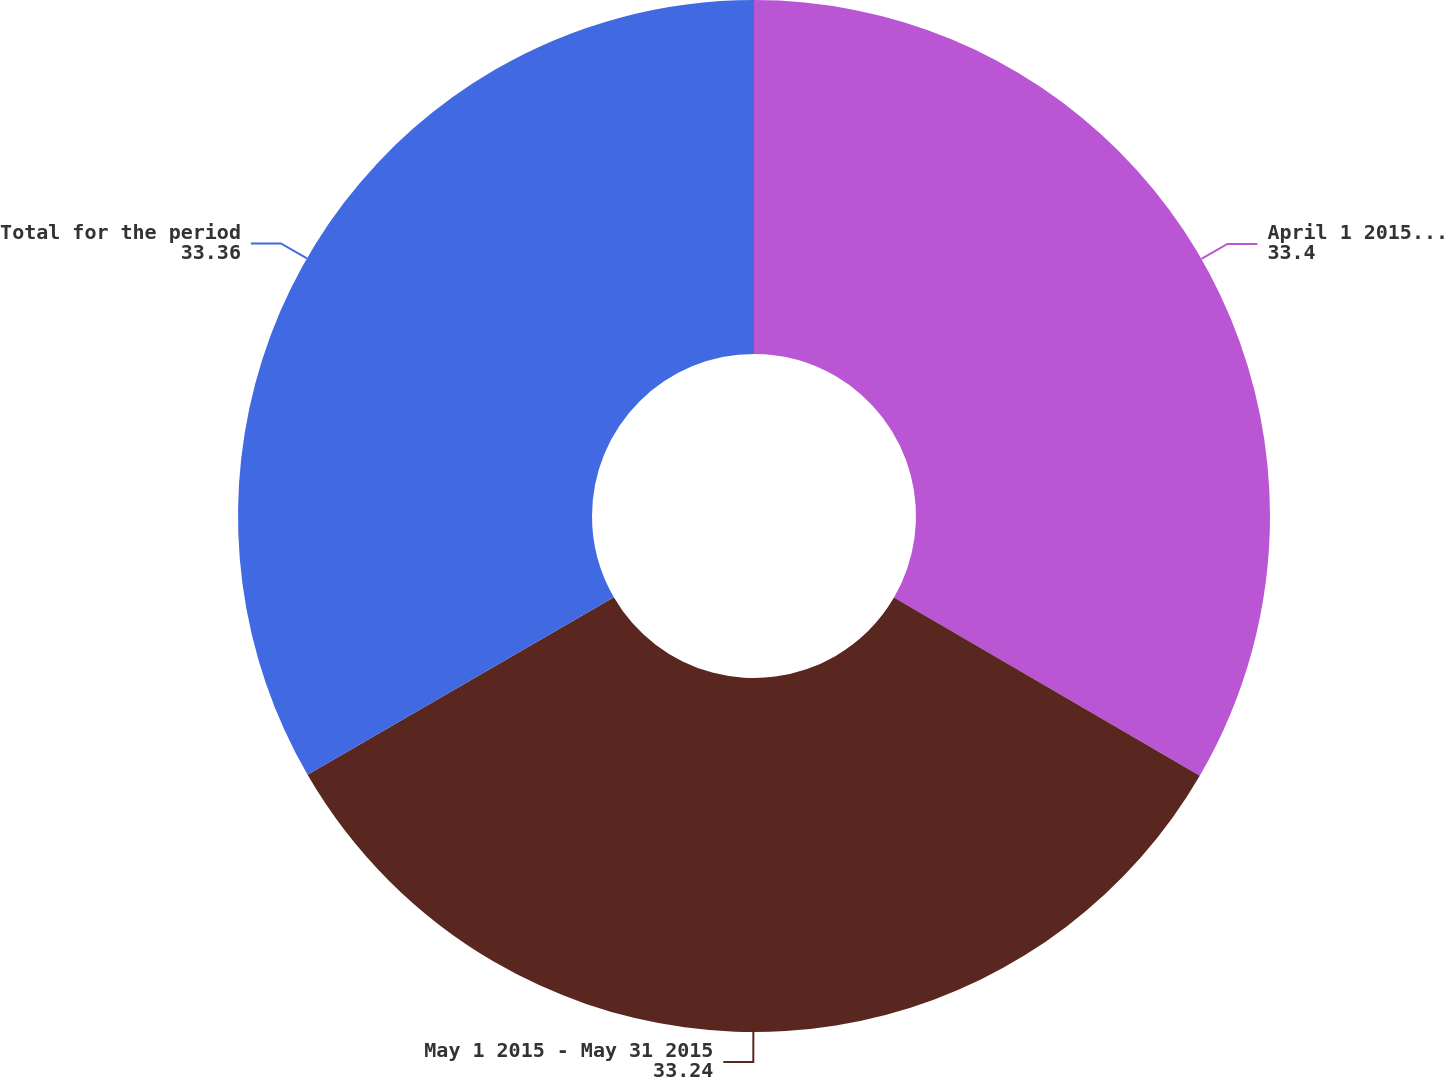Convert chart to OTSL. <chart><loc_0><loc_0><loc_500><loc_500><pie_chart><fcel>April 1 2015 - April 30 2015<fcel>May 1 2015 - May 31 2015<fcel>Total for the period<nl><fcel>33.4%<fcel>33.24%<fcel>33.36%<nl></chart> 